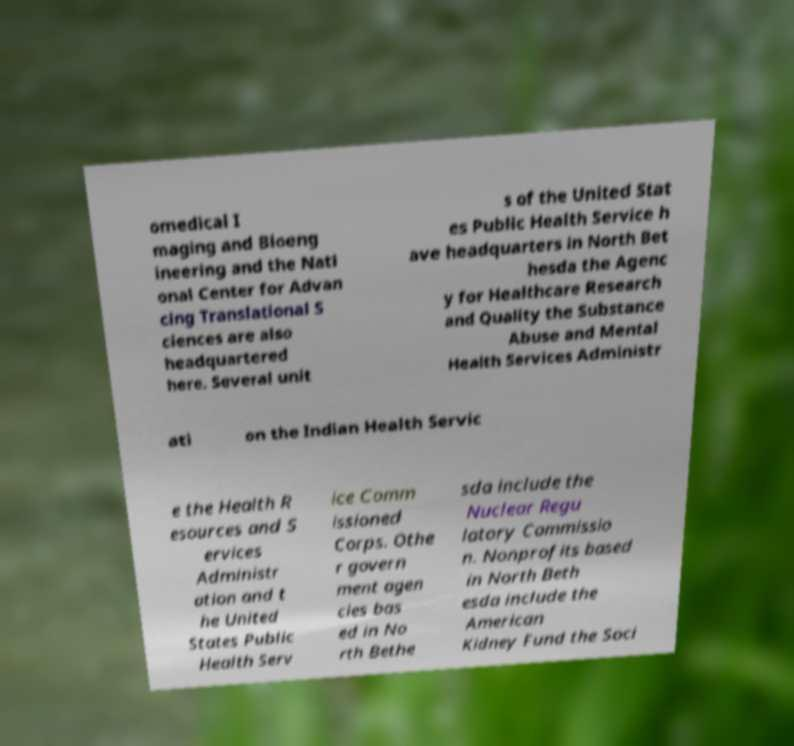For documentation purposes, I need the text within this image transcribed. Could you provide that? omedical I maging and Bioeng ineering and the Nati onal Center for Advan cing Translational S ciences are also headquartered here. Several unit s of the United Stat es Public Health Service h ave headquarters in North Bet hesda the Agenc y for Healthcare Research and Quality the Substance Abuse and Mental Health Services Administr ati on the Indian Health Servic e the Health R esources and S ervices Administr ation and t he United States Public Health Serv ice Comm issioned Corps. Othe r govern ment agen cies bas ed in No rth Bethe sda include the Nuclear Regu latory Commissio n. Nonprofits based in North Beth esda include the American Kidney Fund the Soci 